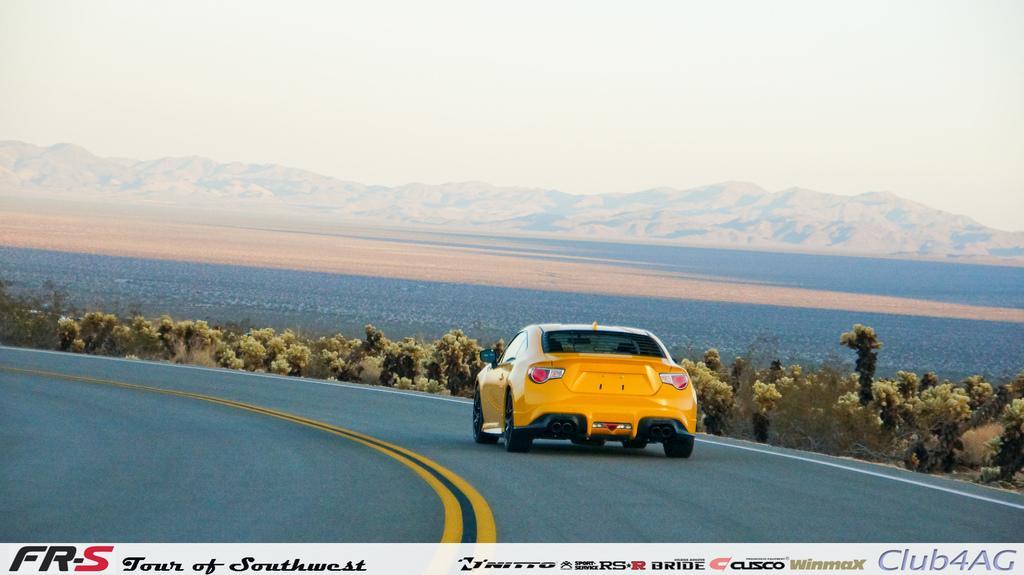Please provide a concise description of this image. In this image we can see the yellow color car moving on the road. Here we can see trees, ground, hills and sky in the background. Here we can see some edited text on the bottom of the image. 